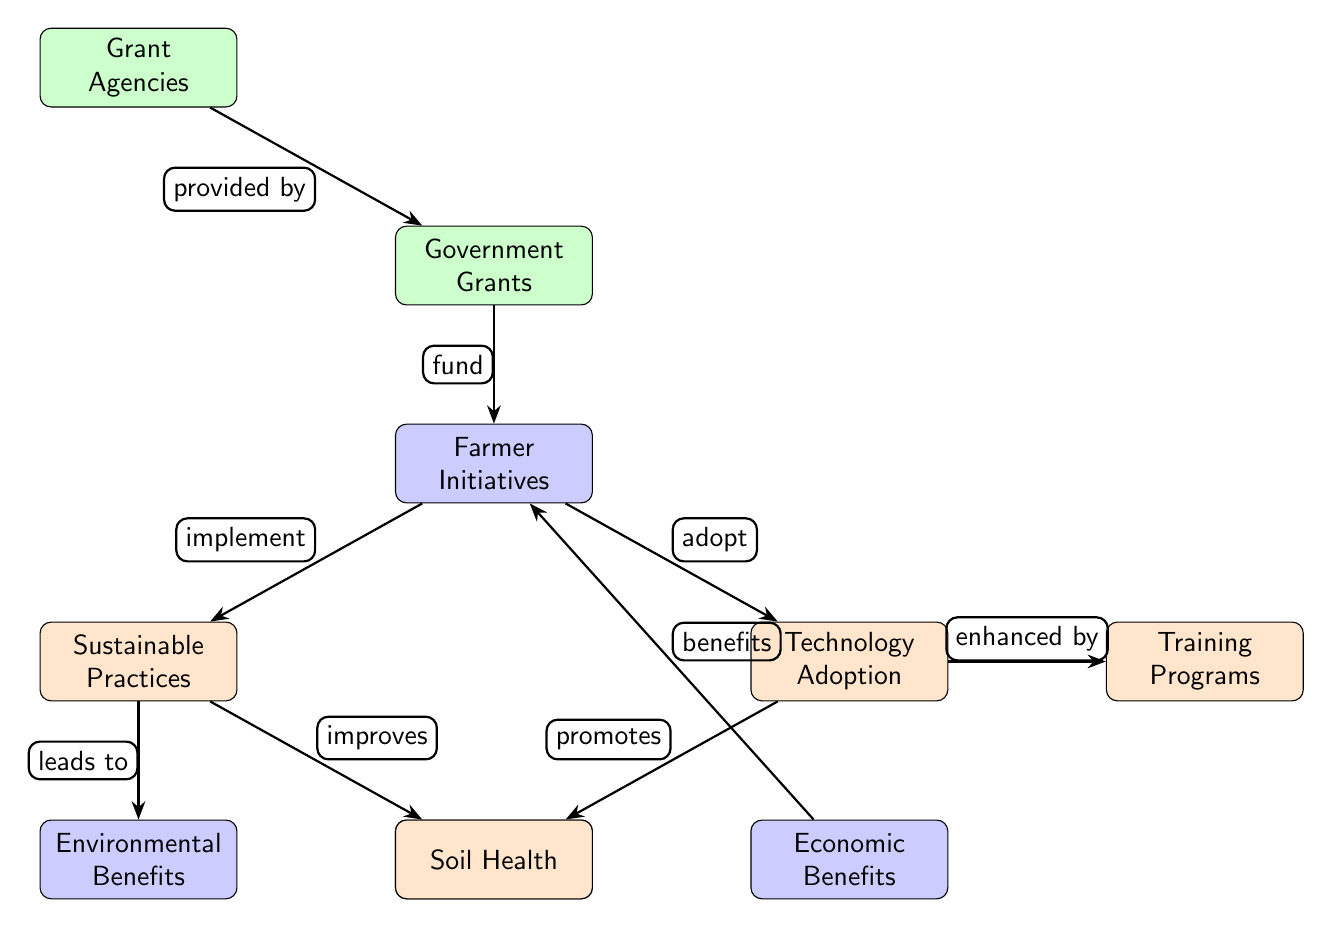What is the main node in the diagram? The main node is labeled "Government Grants," which is positioned at the top of the diagram.
Answer: Government Grants How many secondary nodes are in the diagram? There are three secondary nodes, which are "Farmer Initiatives," "Environmental Benefits," and "Economic Benefits."
Answer: 3 Which node is connected to "Technology Adoption"? The node connected to "Technology Adoption" is "Farmer Initiatives."
Answer: Farmer Initiatives What relationship is indicated between "Sustainable Practices" and "Environmental Benefits"? The diagram indicates that "Sustainable Practices" leads to "Environmental Benefits."
Answer: leads to What benefits are associated with "Economic Benefits" in the diagram? "Economic Benefits" are connected back to "Farmer Initiatives," indicating that they are a result of initiatives taken by farmers after receiving grants.
Answer: benefits What node does "Renewable Energy" promote? "Renewable Energy" is promoted by the node "Technology Adoption."
Answer: Technology Adoption How many edges are there in the diagram? The diagram includes a total of 8 edges connecting the various nodes.
Answer: 8 What node enhances "Training Programs"? The node that enhances "Training Programs" is "Technology Adoption."
Answer: Technology Adoption What type of relationship exists between "Grant Agencies" and "Government Grants"? The relationship is that "Grant Agencies" provide "Government Grants."
Answer: provided by 